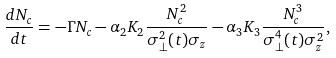Convert formula to latex. <formula><loc_0><loc_0><loc_500><loc_500>\frac { d N _ { c } } { d t } = - \Gamma N _ { c } - \alpha _ { 2 } K _ { 2 } \frac { N _ { c } ^ { 2 } } { \sigma _ { \perp } ^ { 2 } ( t ) \sigma _ { z } } - \alpha _ { 3 } K _ { 3 } \frac { N _ { c } ^ { 3 } } { \sigma _ { \perp } ^ { 4 } ( t ) \sigma ^ { 2 } _ { z } } ,</formula> 